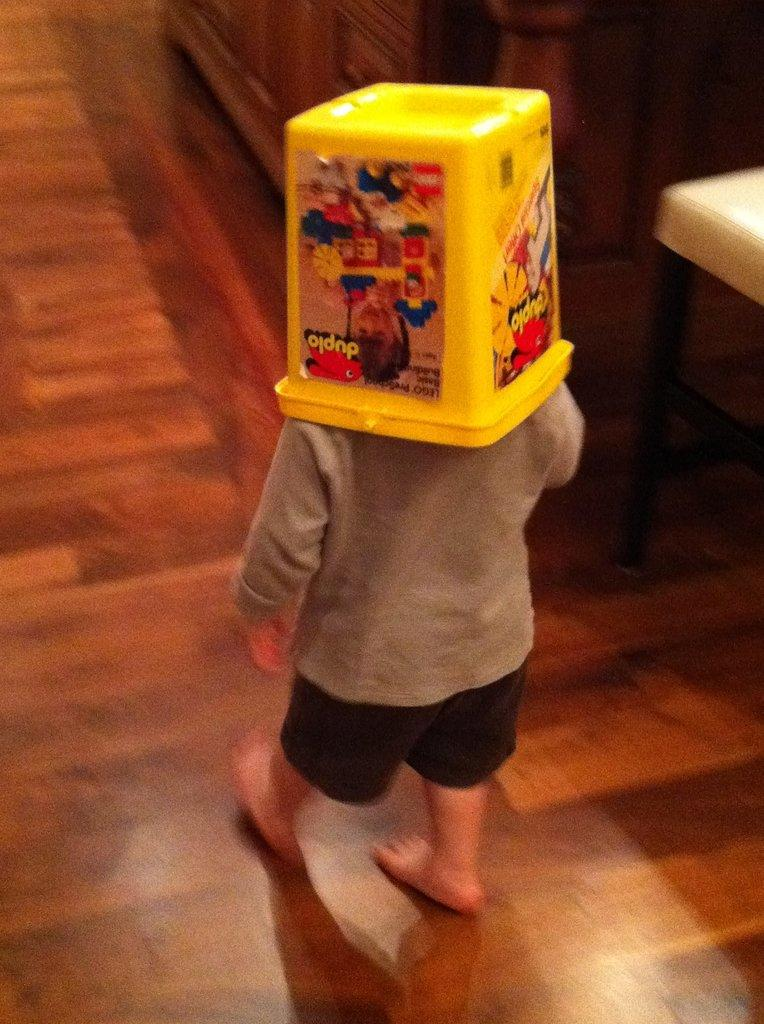What is the main subject of the image? There is a kid in the image. What is the kid doing in the image? The kid is walking on a wooden floor. What is on the kid's head? The kid has a yellow box on his head. What can be seen in the background of the image? There is a cupboard in the background of the image. What is on the right side of the image? There is a white table on the right side of the image. What type of ring can be seen on the kid's finger in the image? There is no ring visible on the kid's finger in the image. What type of scarecrow is present in the image? There is no scarecrow present in the image. 